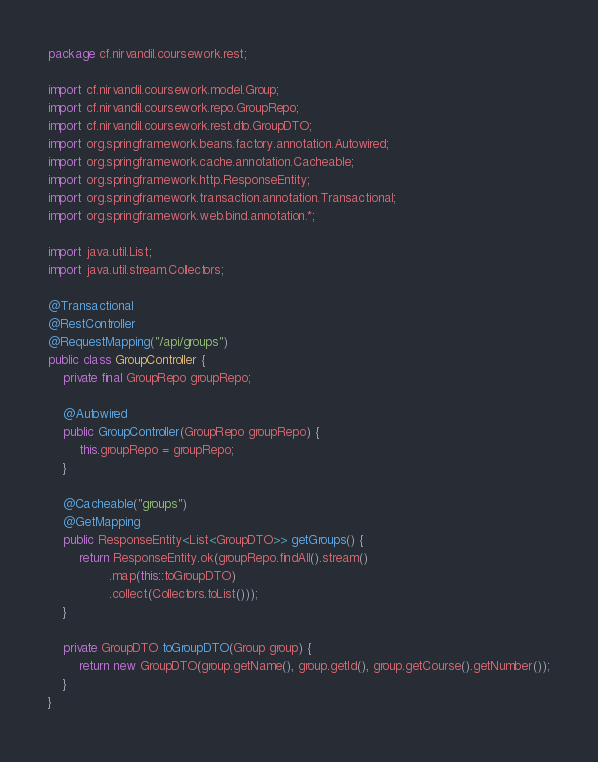Convert code to text. <code><loc_0><loc_0><loc_500><loc_500><_Java_>package cf.nirvandil.coursework.rest;

import cf.nirvandil.coursework.model.Group;
import cf.nirvandil.coursework.repo.GroupRepo;
import cf.nirvandil.coursework.rest.dto.GroupDTO;
import org.springframework.beans.factory.annotation.Autowired;
import org.springframework.cache.annotation.Cacheable;
import org.springframework.http.ResponseEntity;
import org.springframework.transaction.annotation.Transactional;
import org.springframework.web.bind.annotation.*;

import java.util.List;
import java.util.stream.Collectors;

@Transactional
@RestController
@RequestMapping("/api/groups")
public class GroupController {
    private final GroupRepo groupRepo;

    @Autowired
    public GroupController(GroupRepo groupRepo) {
        this.groupRepo = groupRepo;
    }

    @Cacheable("groups")
    @GetMapping
    public ResponseEntity<List<GroupDTO>> getGroups() {
        return ResponseEntity.ok(groupRepo.findAll().stream()
                .map(this::toGroupDTO)
                .collect(Collectors.toList()));
    }

    private GroupDTO toGroupDTO(Group group) {
        return new GroupDTO(group.getName(), group.getId(), group.getCourse().getNumber());
    }
}
</code> 